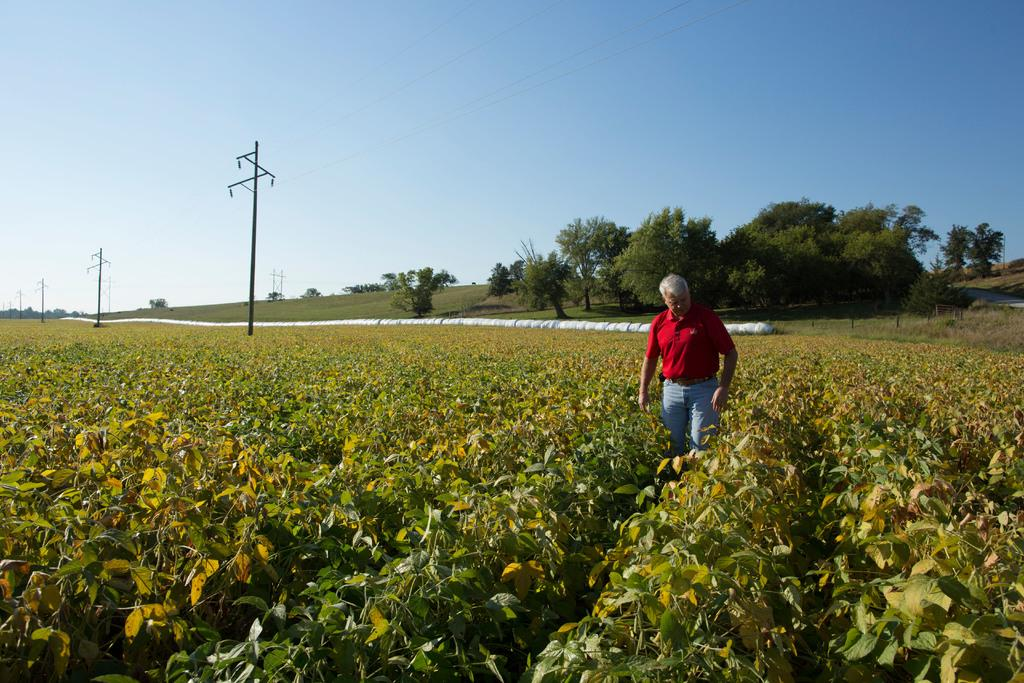What type of living organisms can be seen in the image? Plants can be seen in the image. What is the person in the image doing? The person is standing among the plants. What can be seen in the background of the image? Trees, utility poles, and the sky are visible in the background of the image. What type of meat is being served on the chessboard in the image? There is no meat or chessboard present in the image. 